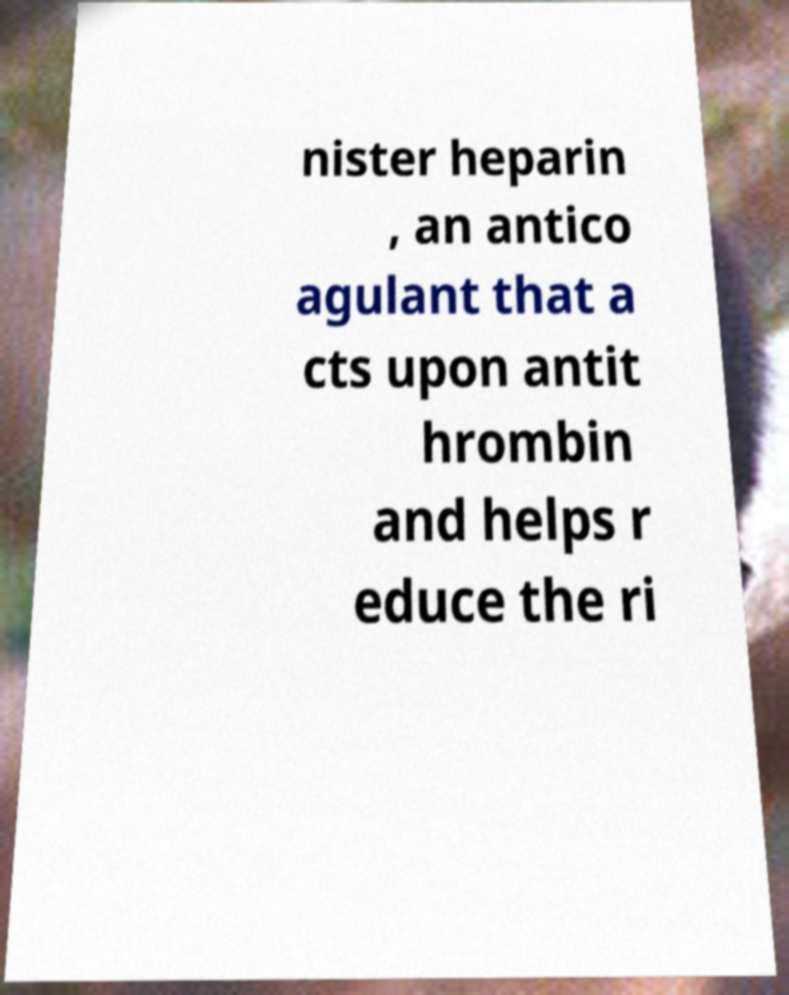I need the written content from this picture converted into text. Can you do that? nister heparin , an antico agulant that a cts upon antit hrombin and helps r educe the ri 